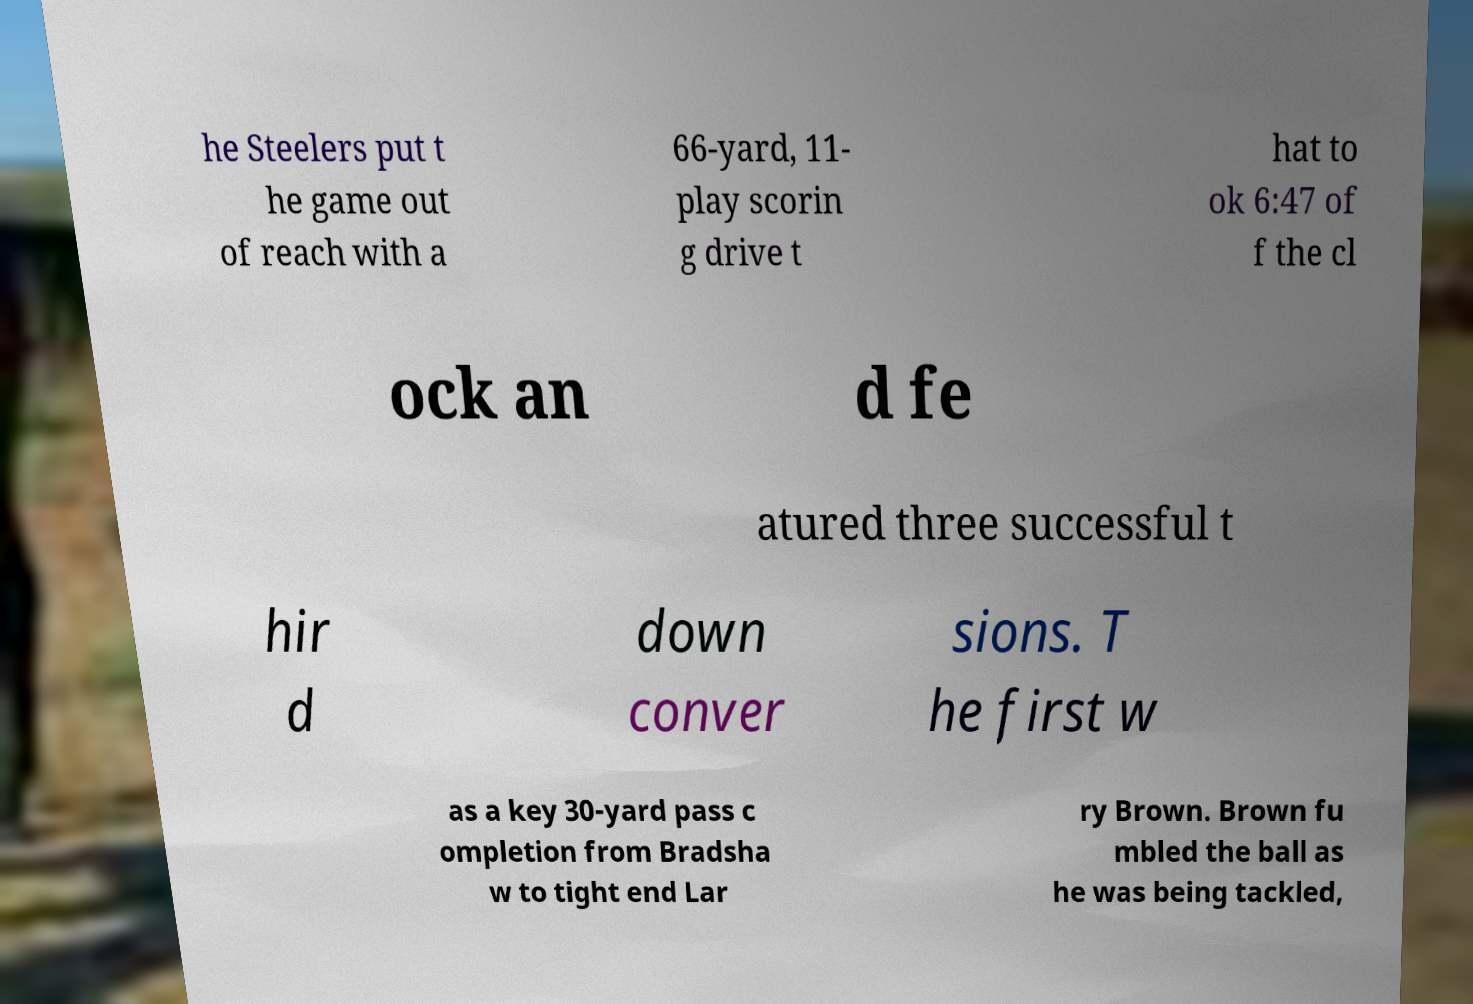Could you extract and type out the text from this image? he Steelers put t he game out of reach with a 66-yard, 11- play scorin g drive t hat to ok 6:47 of f the cl ock an d fe atured three successful t hir d down conver sions. T he first w as a key 30-yard pass c ompletion from Bradsha w to tight end Lar ry Brown. Brown fu mbled the ball as he was being tackled, 